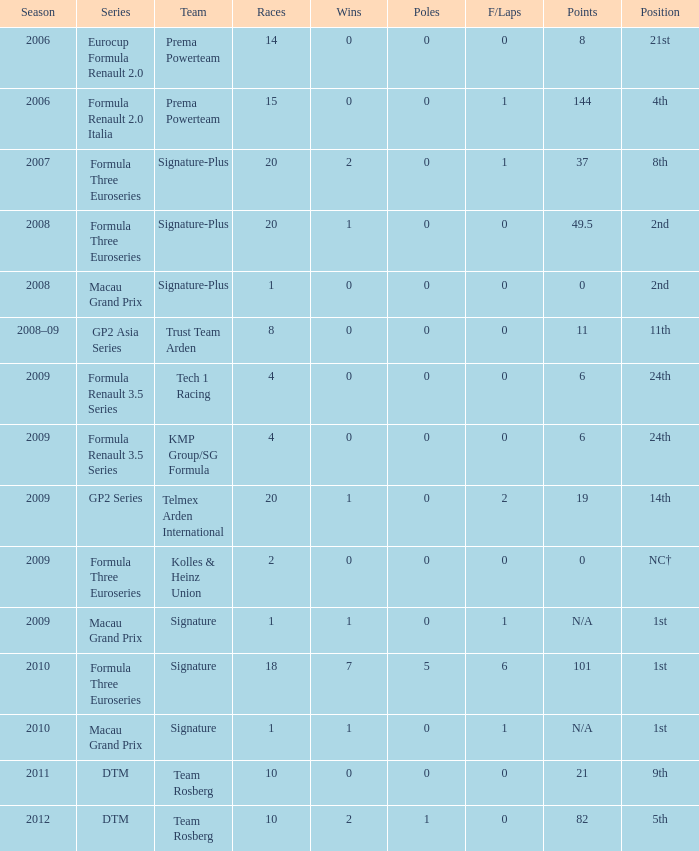How many poles are there in the 2009 season with 2 races and more than 0 F/Laps? 0.0. 